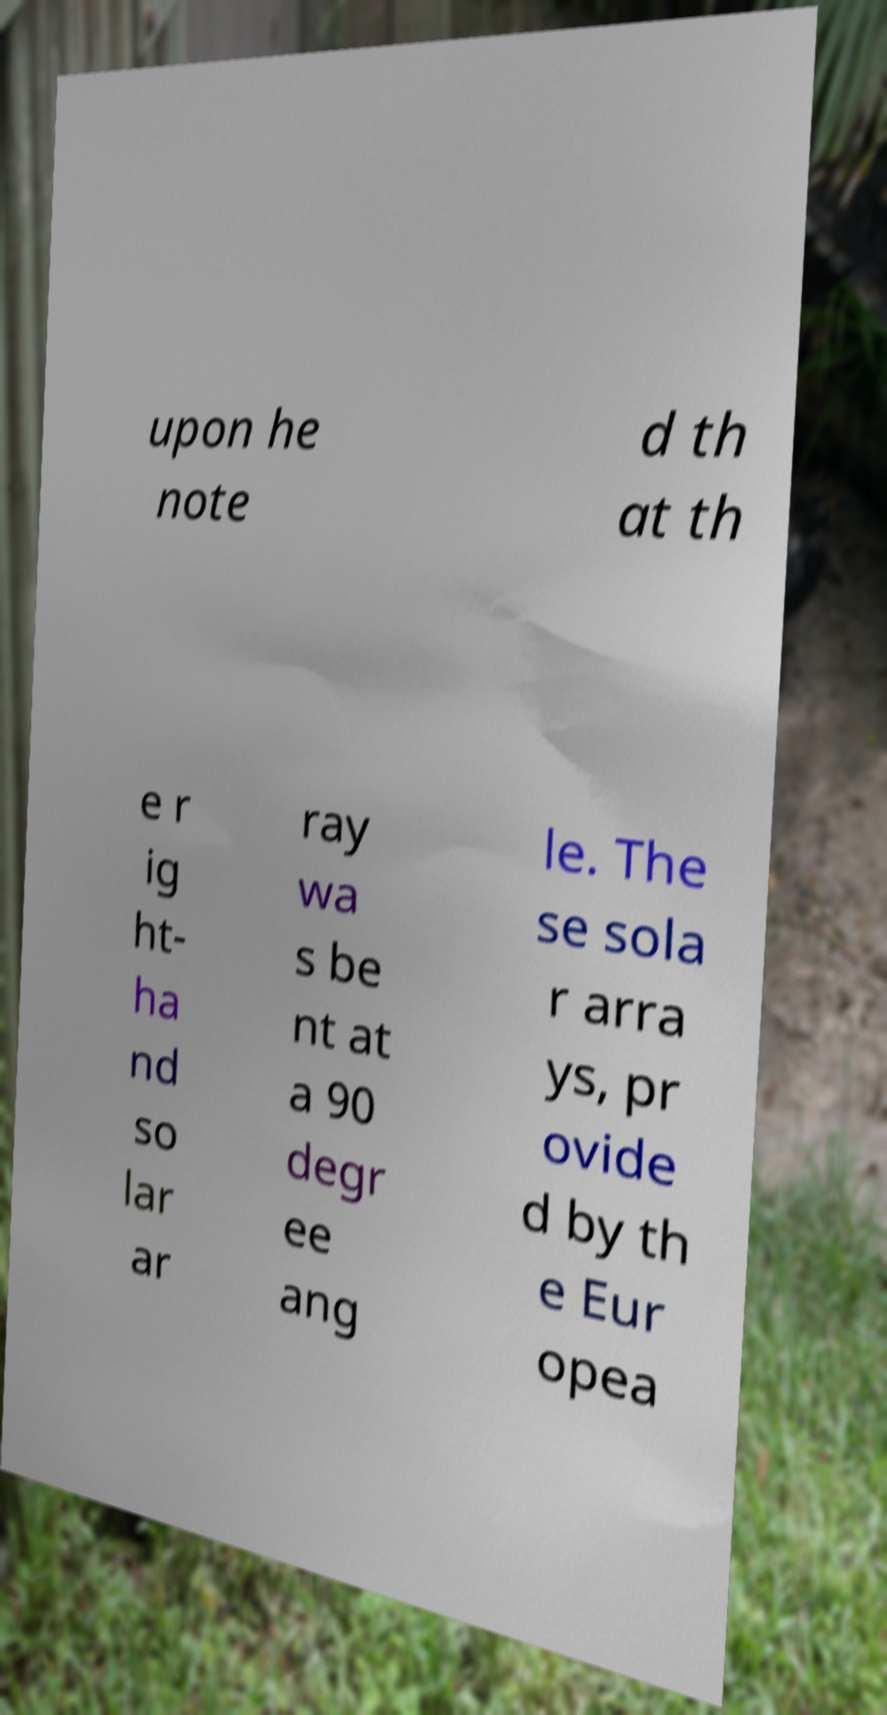Can you accurately transcribe the text from the provided image for me? upon he note d th at th e r ig ht- ha nd so lar ar ray wa s be nt at a 90 degr ee ang le. The se sola r arra ys, pr ovide d by th e Eur opea 